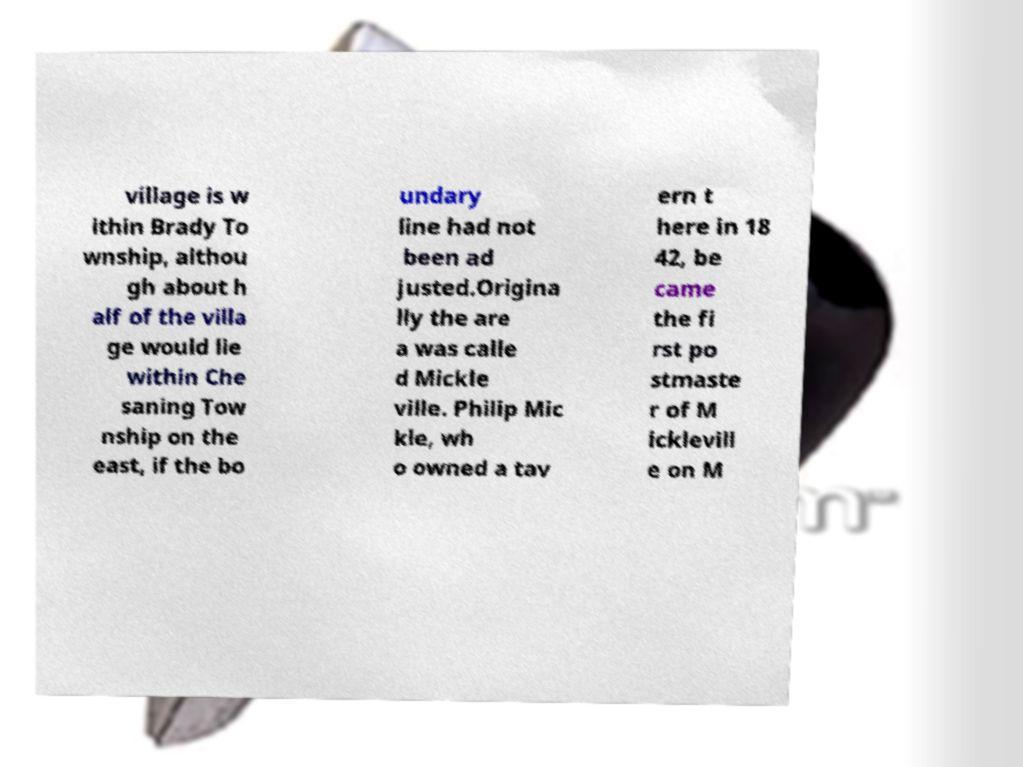Please read and relay the text visible in this image. What does it say? village is w ithin Brady To wnship, althou gh about h alf of the villa ge would lie within Che saning Tow nship on the east, if the bo undary line had not been ad justed.Origina lly the are a was calle d Mickle ville. Philip Mic kle, wh o owned a tav ern t here in 18 42, be came the fi rst po stmaste r of M icklevill e on M 